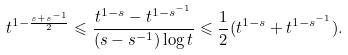Convert formula to latex. <formula><loc_0><loc_0><loc_500><loc_500>t ^ { 1 - \frac { s + s ^ { - 1 } } { 2 } } \leqslant \frac { t ^ { 1 - s } - t ^ { 1 - s ^ { - 1 } } } { ( s - s ^ { - 1 } ) \log t } \leqslant \frac { 1 } { 2 } ( t ^ { 1 - s } + t ^ { 1 - s ^ { - 1 } } ) .</formula> 